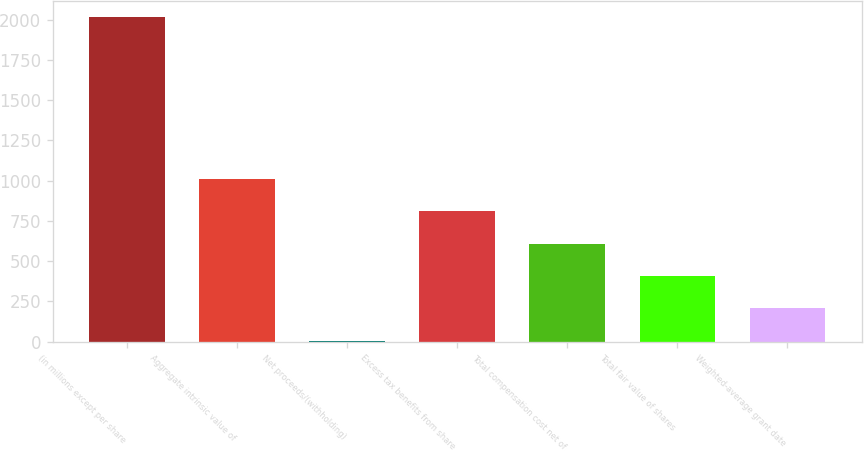Convert chart to OTSL. <chart><loc_0><loc_0><loc_500><loc_500><bar_chart><fcel>(in millions except per share<fcel>Aggregate intrinsic value of<fcel>Net proceeds/(withholding)<fcel>Excess tax benefits from share<fcel>Total compensation cost net of<fcel>Total fair value of shares<fcel>Weighted-average grant date<nl><fcel>2016<fcel>1011<fcel>6<fcel>810<fcel>609<fcel>408<fcel>207<nl></chart> 